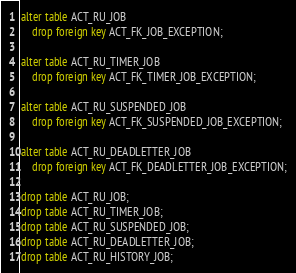<code> <loc_0><loc_0><loc_500><loc_500><_SQL_>alter table ACT_RU_JOB 
    drop foreign key ACT_FK_JOB_EXCEPTION;
    
alter table ACT_RU_TIMER_JOB 
    drop foreign key ACT_FK_TIMER_JOB_EXCEPTION;
    
alter table ACT_RU_SUSPENDED_JOB 
    drop foreign key ACT_FK_SUSPENDED_JOB_EXCEPTION;
    
alter table ACT_RU_DEADLETTER_JOB 
    drop foreign key ACT_FK_DEADLETTER_JOB_EXCEPTION;
    
drop table ACT_RU_JOB;
drop table ACT_RU_TIMER_JOB;
drop table ACT_RU_SUSPENDED_JOB;
drop table ACT_RU_DEADLETTER_JOB;
drop table ACT_RU_HISTORY_JOB;                </code> 